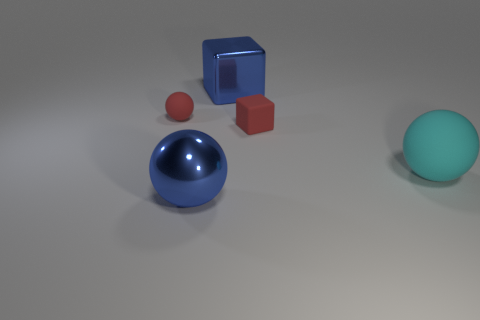Is the color of the metallic cube the same as the metallic ball?
Provide a short and direct response. Yes. Is the number of cyan rubber things that are behind the large rubber ball less than the number of big blue things that are behind the tiny rubber cube?
Your answer should be very brief. Yes. Do the large blue ball and the tiny red cube have the same material?
Give a very brief answer. No. There is a matte thing that is behind the cyan rubber thing and in front of the red matte ball; what is its size?
Give a very brief answer. Small. The rubber object that is the same size as the metal cube is what shape?
Your answer should be very brief. Sphere. What is the material of the large blue thing that is in front of the red matte thing that is to the right of the big thing behind the tiny block?
Your response must be concise. Metal. There is a blue shiny thing behind the tiny red cube; does it have the same shape as the red thing in front of the small rubber ball?
Ensure brevity in your answer.  Yes. What number of other objects are there of the same material as the tiny red cube?
Ensure brevity in your answer.  2. Do the block behind the red rubber sphere and the tiny red ball to the left of the large cyan thing have the same material?
Your answer should be compact. No. There is a tiny thing that is the same material as the red ball; what is its shape?
Your answer should be compact. Cube. 